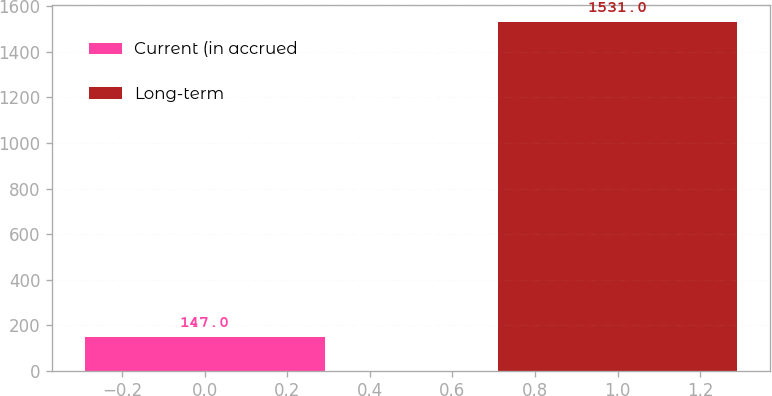Convert chart to OTSL. <chart><loc_0><loc_0><loc_500><loc_500><bar_chart><fcel>Current (in accrued<fcel>Long-term<nl><fcel>147<fcel>1531<nl></chart> 